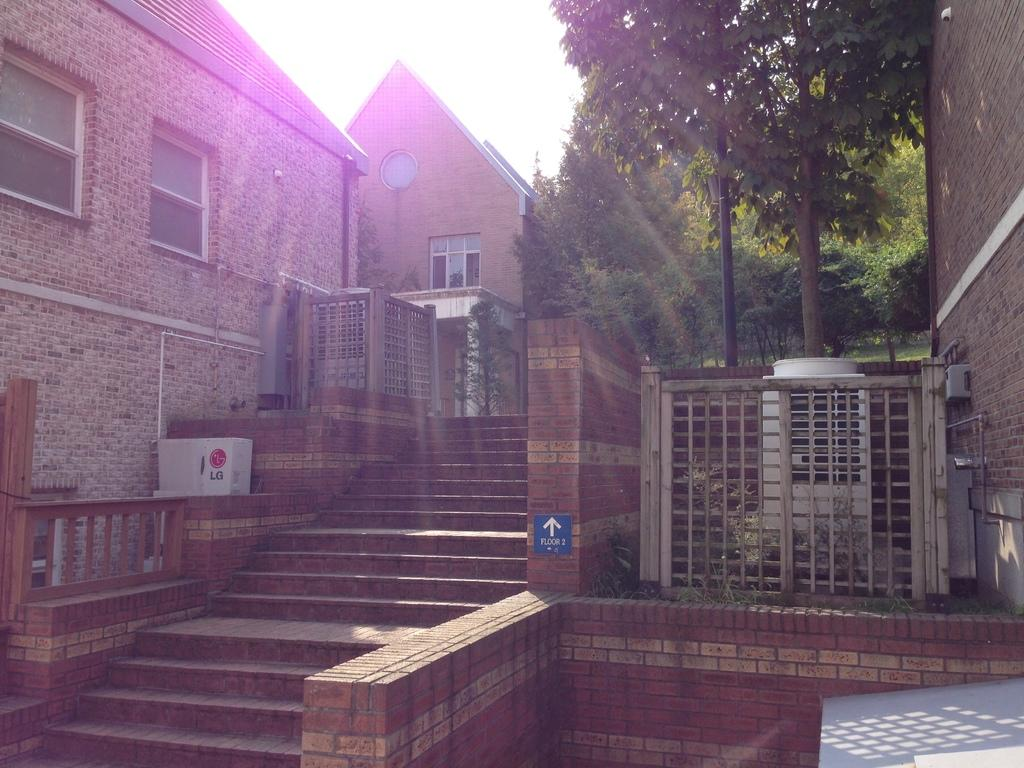What type of structure is present in the image? There is a building in the image. What can be seen in the background of the image? There are many trees in the image. How many objects are visible in the image? There are few objects in the image. What is on the wall in the image? There is a board on the wall in the image. What is visible at the top of the image? The sky is visible in the image. What type of zephyr can be seen blowing through the trees in the image? There is no zephyr present in the image; it is a term used to describe a gentle breeze, and there is no mention of wind or breeze in the provided facts. 